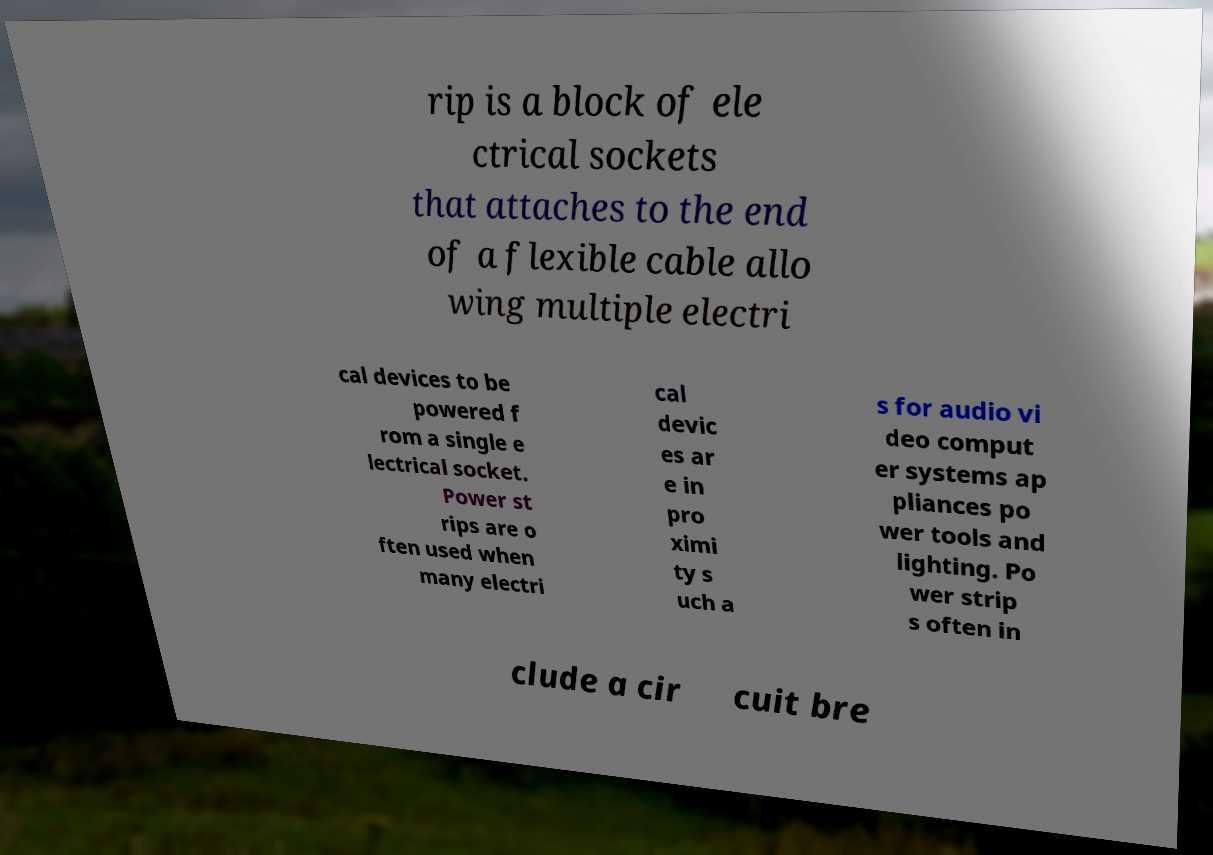I need the written content from this picture converted into text. Can you do that? rip is a block of ele ctrical sockets that attaches to the end of a flexible cable allo wing multiple electri cal devices to be powered f rom a single e lectrical socket. Power st rips are o ften used when many electri cal devic es ar e in pro ximi ty s uch a s for audio vi deo comput er systems ap pliances po wer tools and lighting. Po wer strip s often in clude a cir cuit bre 